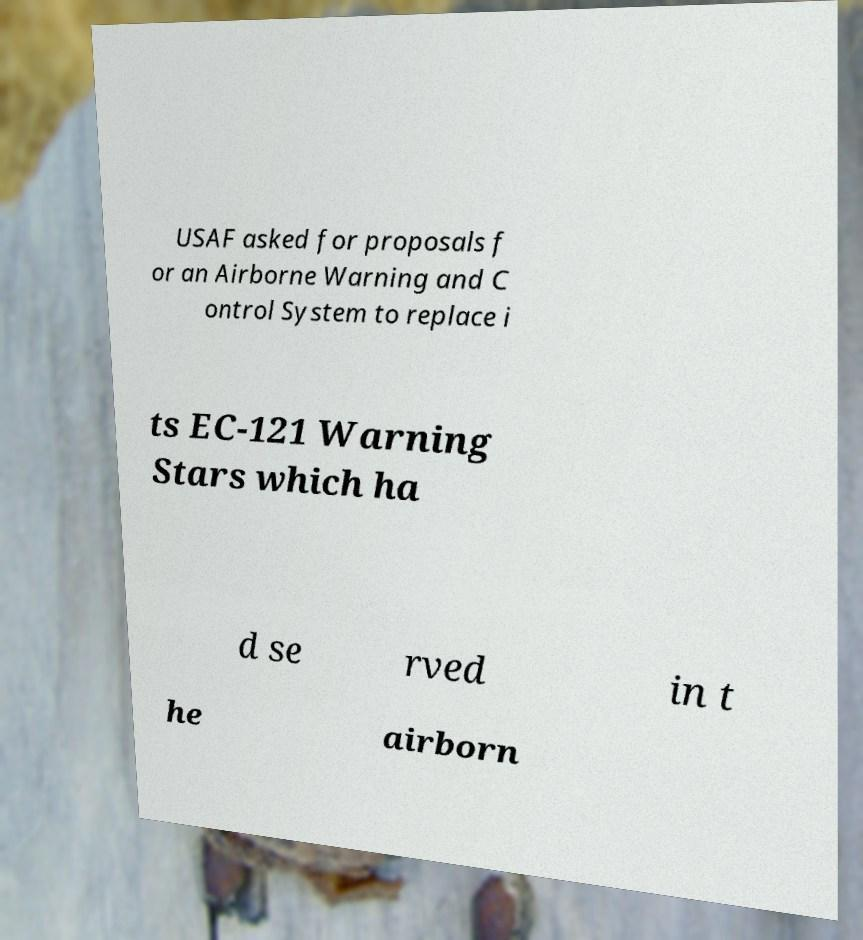Can you read and provide the text displayed in the image?This photo seems to have some interesting text. Can you extract and type it out for me? USAF asked for proposals f or an Airborne Warning and C ontrol System to replace i ts EC-121 Warning Stars which ha d se rved in t he airborn 